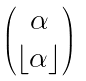Convert formula to latex. <formula><loc_0><loc_0><loc_500><loc_500>\begin{pmatrix} \alpha \\ \lfloor \alpha \rfloor \end{pmatrix}</formula> 